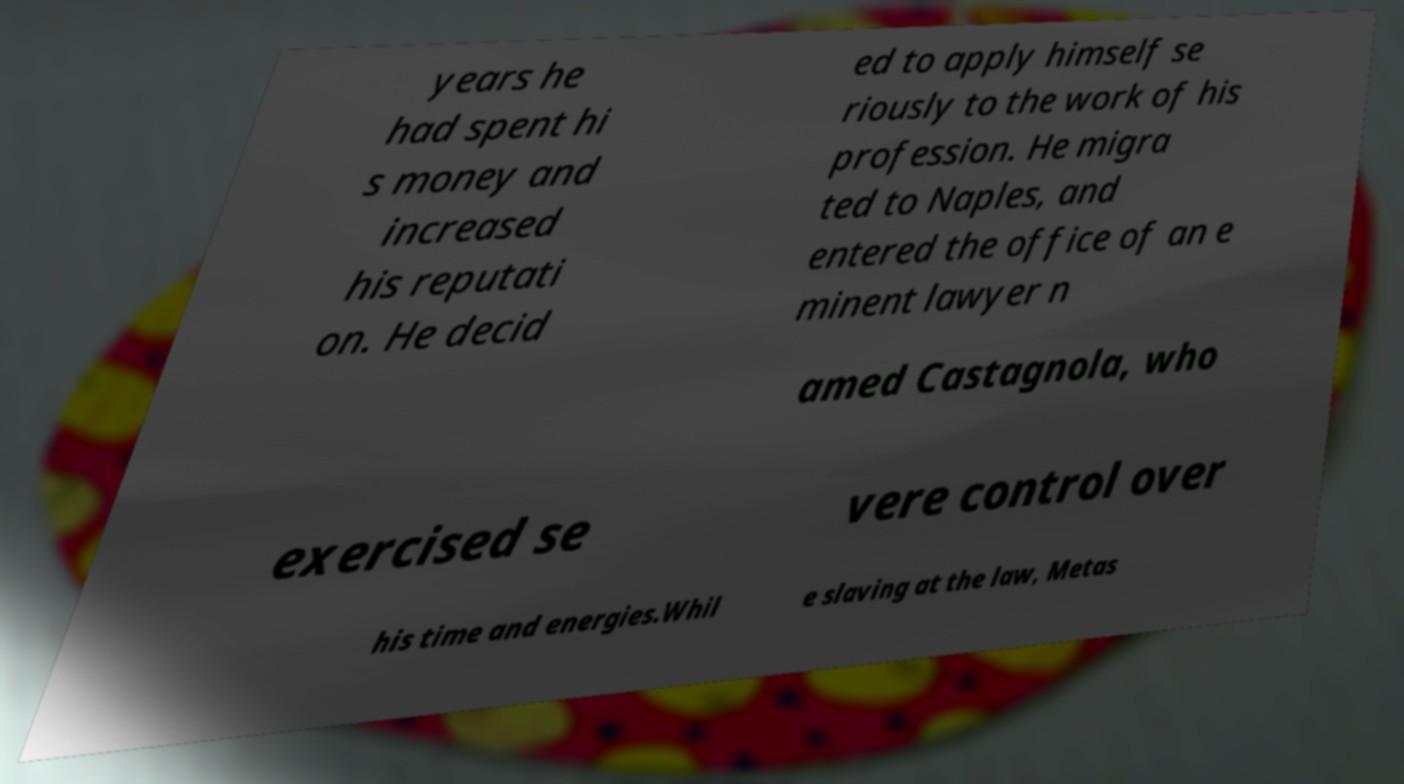Please read and relay the text visible in this image. What does it say? years he had spent hi s money and increased his reputati on. He decid ed to apply himself se riously to the work of his profession. He migra ted to Naples, and entered the office of an e minent lawyer n amed Castagnola, who exercised se vere control over his time and energies.Whil e slaving at the law, Metas 